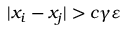Convert formula to latex. <formula><loc_0><loc_0><loc_500><loc_500>| x _ { i } - x _ { j } | > c \gamma \varepsilon</formula> 